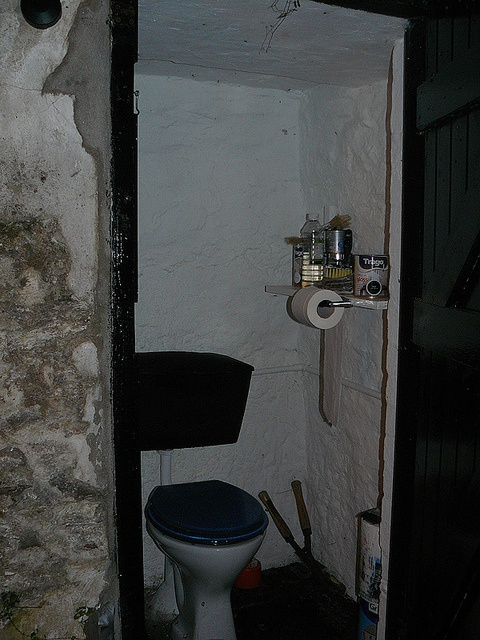Describe the objects in this image and their specific colors. I can see toilet in gray, black, and purple tones and bottle in gray, black, and purple tones in this image. 